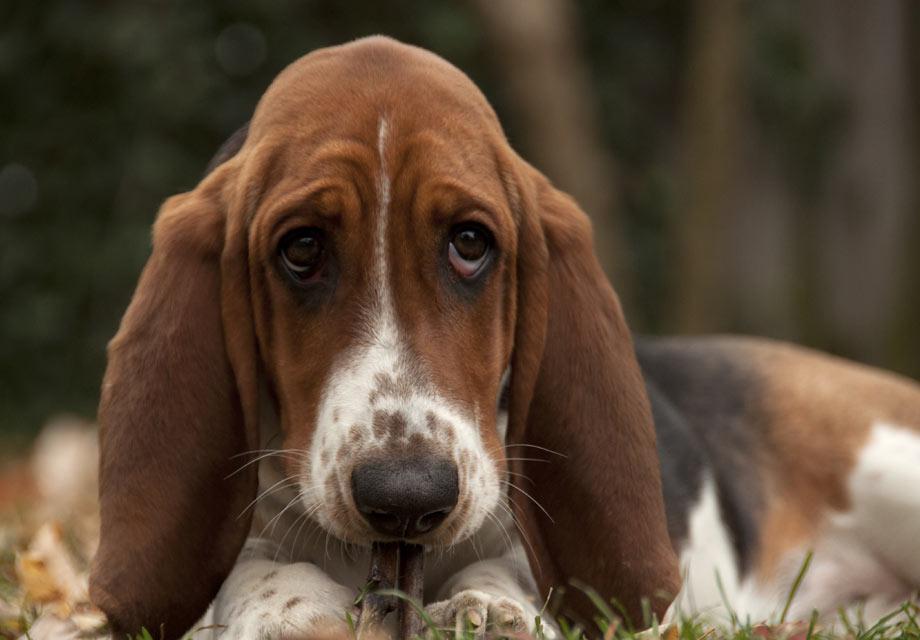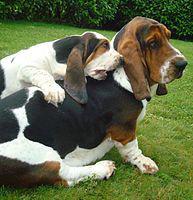The first image is the image on the left, the second image is the image on the right. For the images displayed, is the sentence "In one image, a dog with big floppy ears is running." factually correct? Answer yes or no. No. The first image is the image on the left, the second image is the image on the right. Assess this claim about the two images: "One image shows a basset hound bounding toward the camera.". Correct or not? Answer yes or no. No. 